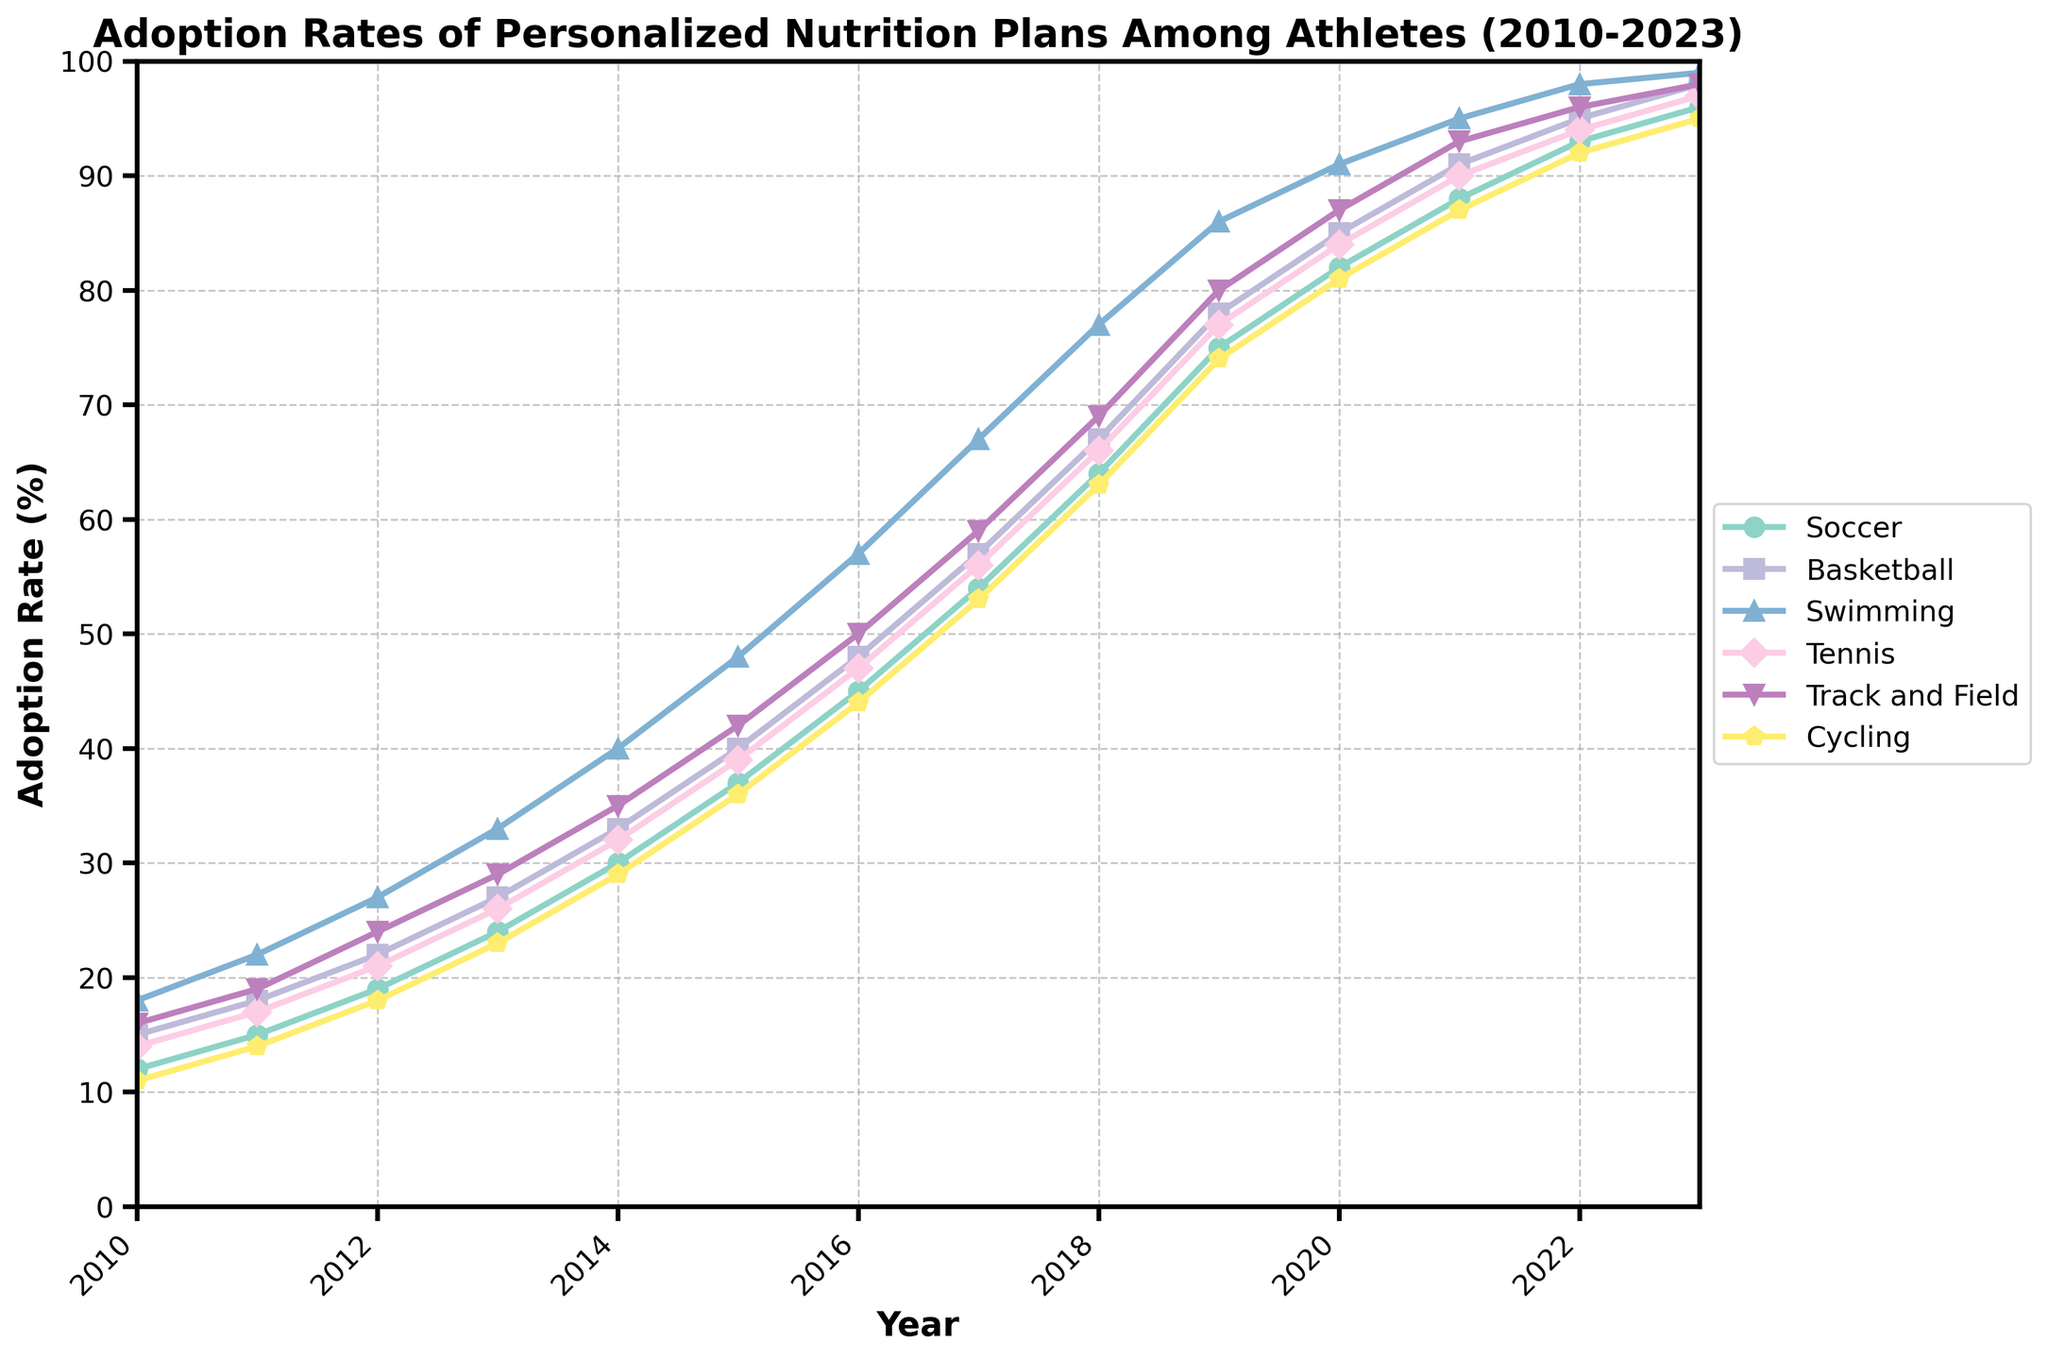What is the adoption rate for Basketball in 2020? The line chart shows the adoption rates of personalized nutrition plans among athletes in various sports from 2010 to 2023. For Basketball in 2020, refer to the Basketball line and locate the value for 2020 on the x-axis.
Answer: 85 Which sport had the highest adoption rate in 2015? To determine which sport had the highest adoption rate in 2015, compare the y-values at the 2015 mark for all the sports. Swimming has the highest value.
Answer: Swimming Between what years did Soccer experience the most significant increase in adoption rates? To find the period of the most significant increase, compare the differences between consecutive years for Soccer. The most significant increase for Soccer was between 2018 (64) and 2019 (75).
Answer: 2018 and 2019 By how much did the adoption rate for Tennis increase from 2012 to 2015? To find the increase, subtract the 2012 adoption rate for Tennis from the 2015 adoption rate. For Tennis, it was 39 (2015) - 21 (2012).
Answer: 18 Which sport showed a consistent increase in adoption rates every year? Look for a sport where the adoption rate increases every consecutive year without any drops. All the sports shown indicate consistent increases each year.
Answer: All sports What was the average adoption rate of Cycling from 2010 to 2013? To calculate the average, add the adoption rates for Cycling from 2010 to 2013 and divide by the number of years. (11 + 14 + 18 + 23) / 4.
Answer: 16.5 In which year did Track and Field surpass a 50% adoption rate? Track and Field surpassed 50% in the year where the rate first exceeds 50. It was in 2016.
Answer: 2016 Compare the adoption rates of Soccer and Swimming in 2023. Which is higher and by how much? Referring to 2023 values for both sports, compare the rates. Swimming is higher at 99 while Soccer is at 96. The difference is 99 - 96.
Answer: Swimming by 3 What is the difference in adoption rates between Cycling and Soccer in 2017? Subtract the adoption rate of Cycling from Soccer in 2017. Soccer is at 54, and Cycling is at 53, so the difference is 54 - 53.
Answer: 1 Which sport had the lowest adoption rate in 2014, and what was it? Compare the adoption rates across all sports in 2014. Cycling had the lowest rate at 29.
Answer: Cycling with 29 